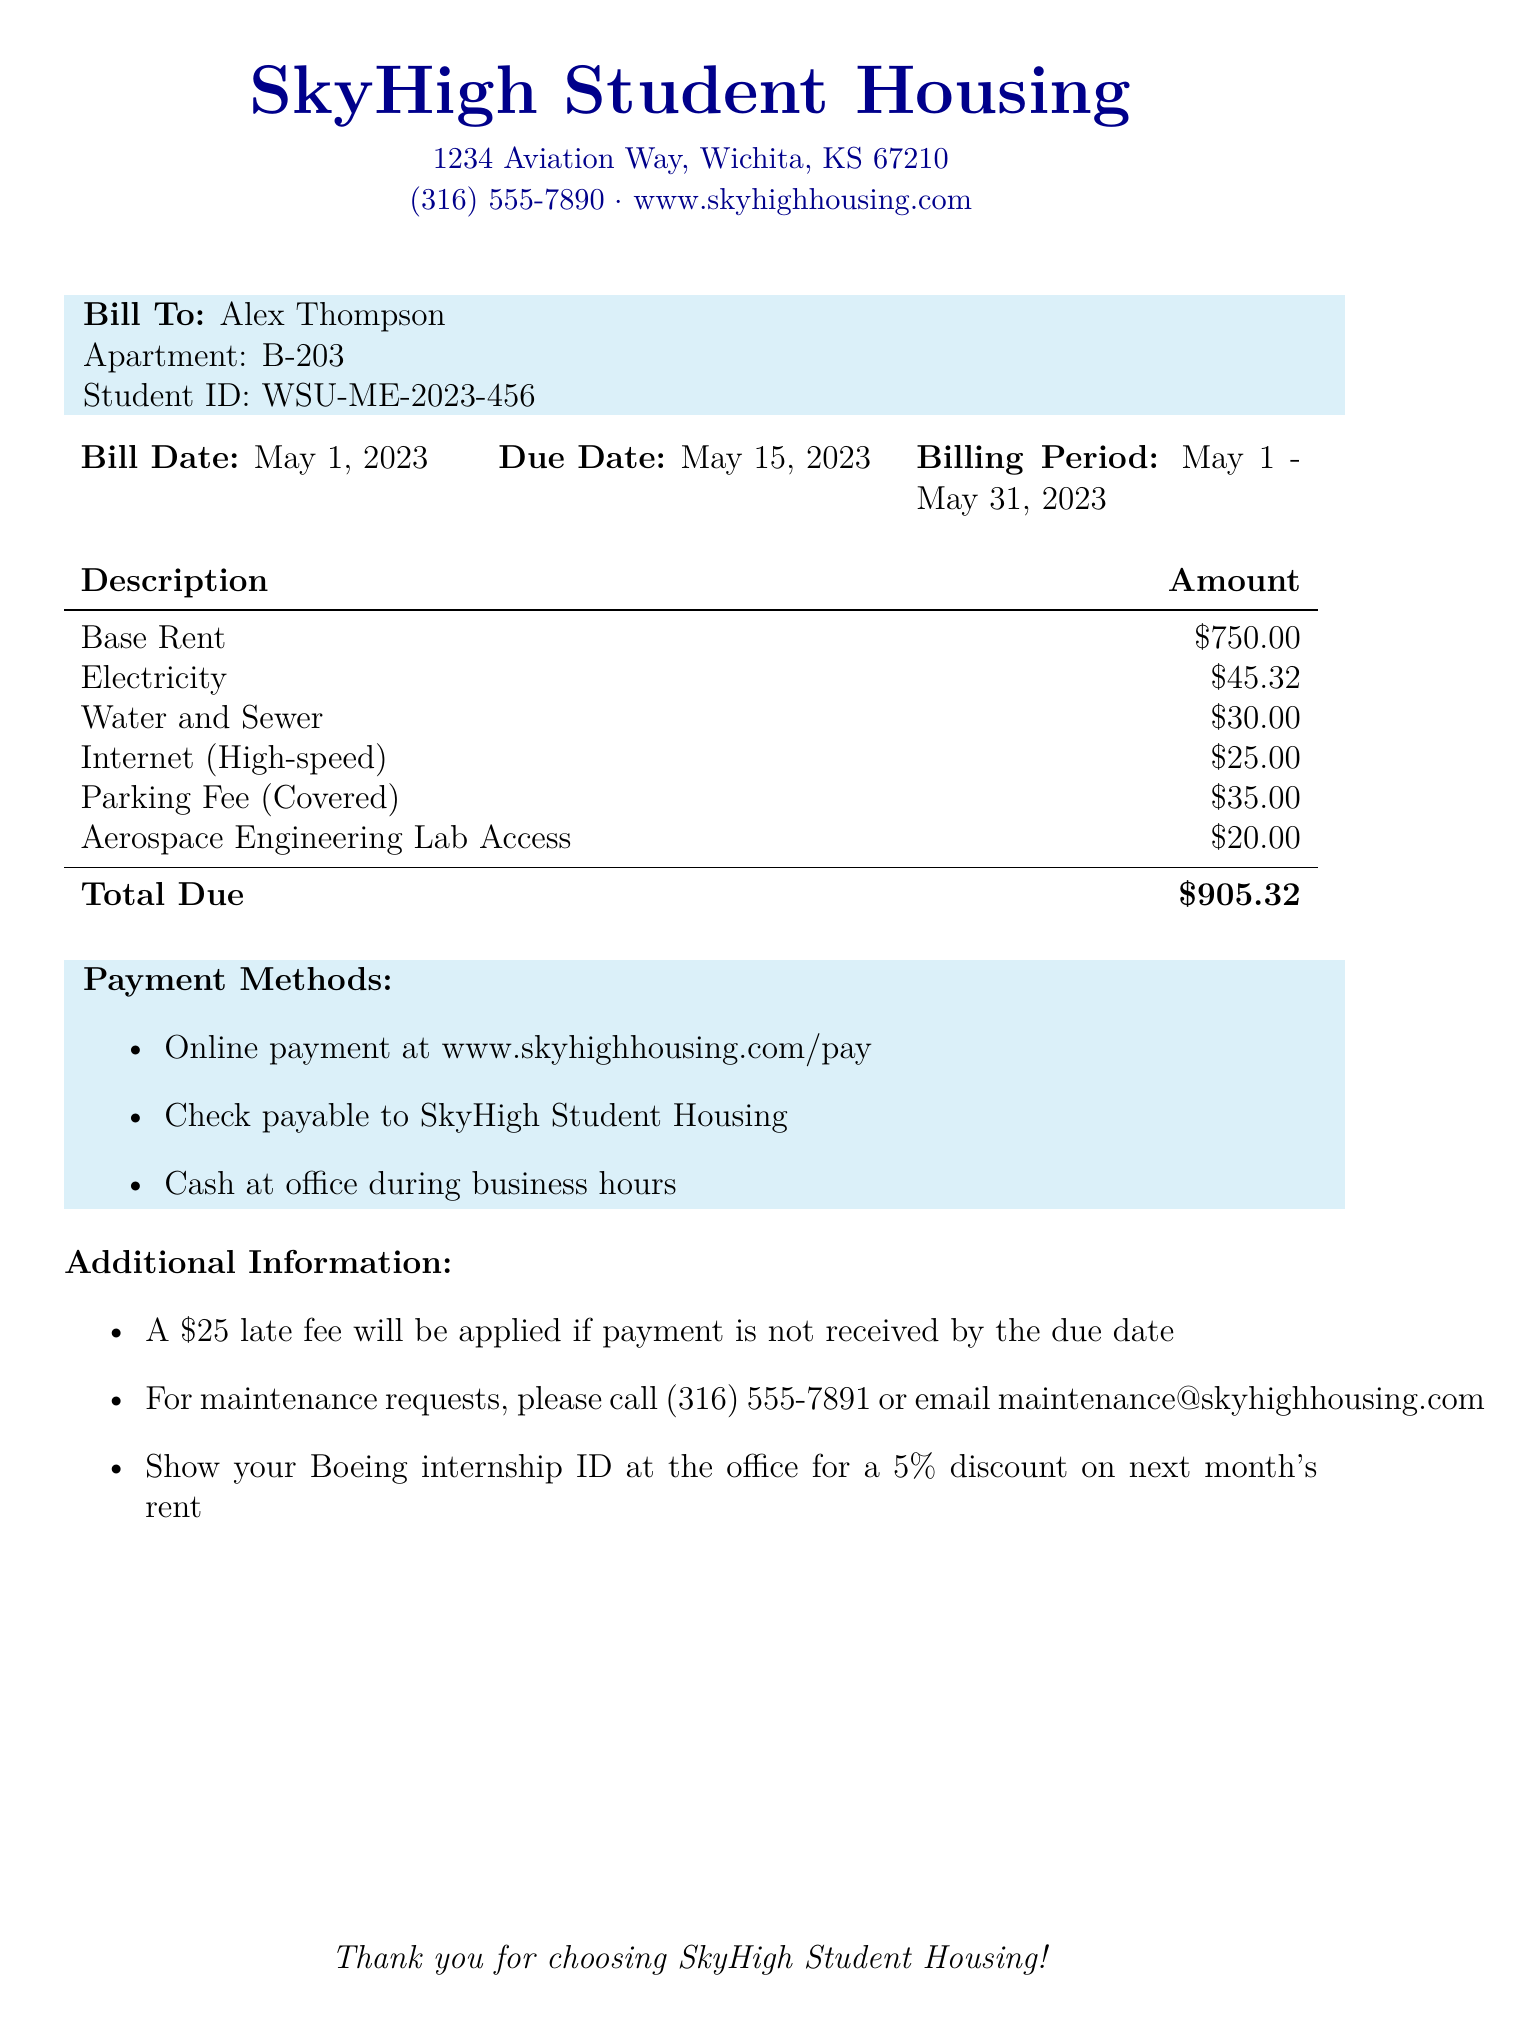what is the total due amount? The total due amount is listed in the bill under "Total Due," which encompasses all charges for the billing period.
Answer: $905.32 what is the base rent? The base rent is the primary charge for the apartment and is explicitly listed in the document.
Answer: $750.00 when is the due date for the bill? The due date is specified in the document as the deadline for payment.
Answer: May 15, 2023 how much is the parking fee? The parking fee is specifically itemized in the bill and can be found among the utility fees.
Answer: $35.00 what would be the late fee if payment is not received by the due date? The late fee is mentioned under additional information as a potential penalty if the bill is not paid on time.
Answer: $25 how can a tenant reduce next month's rent? The method to obtain a discount on next month's rent is outlined in the additional information section.
Answer: Show Boeing internship ID what is the billing period for this bill? The billing period specifies the duration for which the charges apply and is included in the header of the document.
Answer: May 1 - May 31, 2023 what service costs $20.00? The specific service for which this fee is charged is directly referenced in the itemized list.
Answer: Aerospace Engineering Lab Access how can payments be made? The document outlines several methods for submitting payment, providing options available to the tenant.
Answer: Online, Check, Cash 